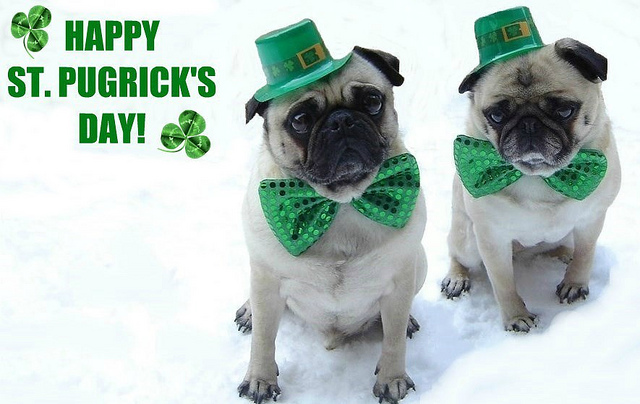Can you craft a short story based on this image? Once upon a time, in a cozy town covered in fresh snow, two pugs named Paddy and Clovers were getting ready for the annual St. Patrick’s Day parade. Paddy, known for his love of festivities, meticulously adjusted Clovers' bow tie and ensured their hats were perfectly snuggled. As they stepped outside, they were greeted by cheers from the townsfolk who adored their spirit and effort. This year, more than ever, Paddy and Clovers felt the warmth of community and the joy of friendship. What dialogue might these pugs have if they were celebrating St. Patrick's Day? Paddy: 'Clovers, did you see how everyone cheered when we came out? I told you these hats would be a hit!' Clovers: 'Yes, Paddy, you were right. I'm just glad we didn’t forget the bow ties. It’s the little details that count!' Paddy: 'Exactly! Now, let’s find some treats. What do you say to that?' Clovers: 'Treats? You read my mind!' 